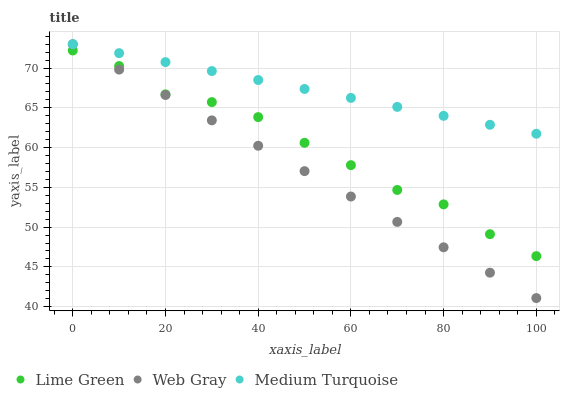Does Web Gray have the minimum area under the curve?
Answer yes or no. Yes. Does Medium Turquoise have the maximum area under the curve?
Answer yes or no. Yes. Does Lime Green have the minimum area under the curve?
Answer yes or no. No. Does Lime Green have the maximum area under the curve?
Answer yes or no. No. Is Medium Turquoise the smoothest?
Answer yes or no. Yes. Is Lime Green the roughest?
Answer yes or no. Yes. Is Lime Green the smoothest?
Answer yes or no. No. Is Medium Turquoise the roughest?
Answer yes or no. No. Does Web Gray have the lowest value?
Answer yes or no. Yes. Does Lime Green have the lowest value?
Answer yes or no. No. Does Medium Turquoise have the highest value?
Answer yes or no. Yes. Does Lime Green have the highest value?
Answer yes or no. No. Is Lime Green less than Medium Turquoise?
Answer yes or no. Yes. Is Medium Turquoise greater than Lime Green?
Answer yes or no. Yes. Does Web Gray intersect Lime Green?
Answer yes or no. Yes. Is Web Gray less than Lime Green?
Answer yes or no. No. Is Web Gray greater than Lime Green?
Answer yes or no. No. Does Lime Green intersect Medium Turquoise?
Answer yes or no. No. 